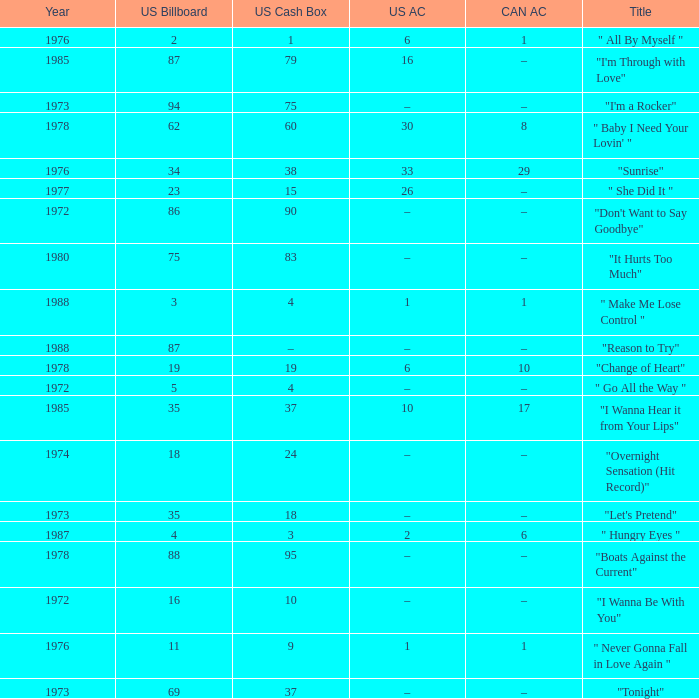What is the US cash box before 1978 with a US billboard of 35? 18.0. 